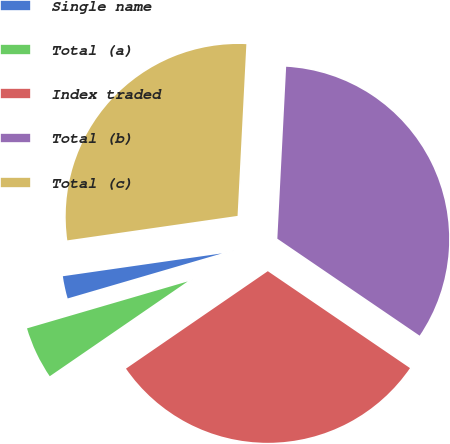Convert chart to OTSL. <chart><loc_0><loc_0><loc_500><loc_500><pie_chart><fcel>Single name<fcel>Total (a)<fcel>Index traded<fcel>Total (b)<fcel>Total (c)<nl><fcel>2.25%<fcel>5.06%<fcel>30.9%<fcel>33.71%<fcel>28.09%<nl></chart> 